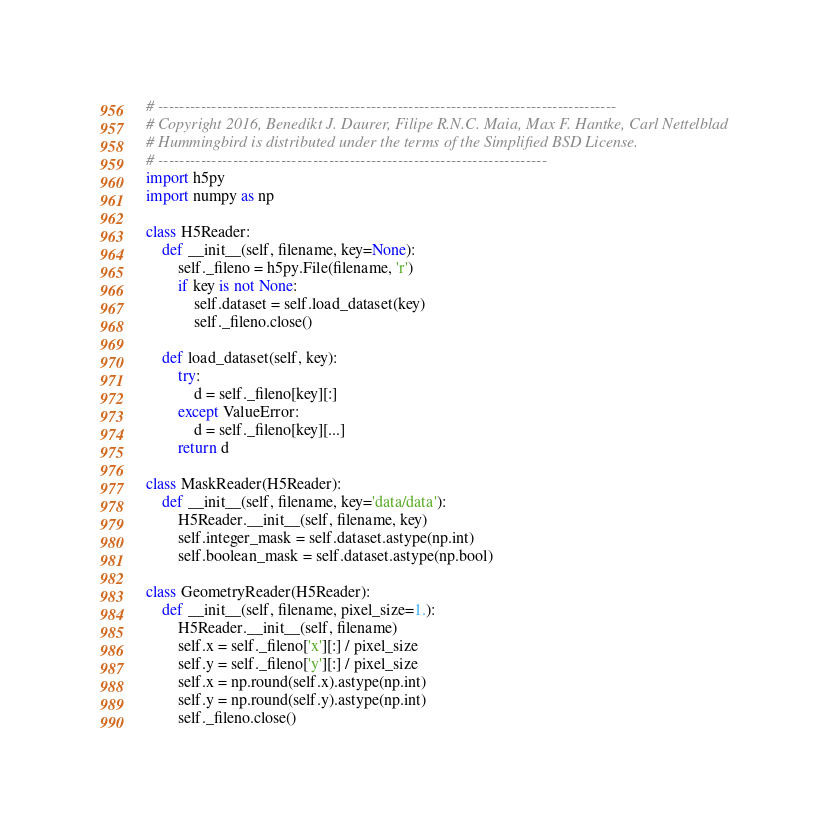<code> <loc_0><loc_0><loc_500><loc_500><_Python_># --------------------------------------------------------------------------------------
# Copyright 2016, Benedikt J. Daurer, Filipe R.N.C. Maia, Max F. Hantke, Carl Nettelblad
# Hummingbird is distributed under the terms of the Simplified BSD License.
# -------------------------------------------------------------------------
import h5py
import numpy as np

class H5Reader:
    def __init__(self, filename, key=None):
        self._fileno = h5py.File(filename, 'r')
        if key is not None:
            self.dataset = self.load_dataset(key)
            self._fileno.close()
            
    def load_dataset(self, key):
        try:
            d = self._fileno[key][:]
        except ValueError:
            d = self._fileno[key][...]
        return d
        
class MaskReader(H5Reader):
    def __init__(self, filename, key='data/data'):
        H5Reader.__init__(self, filename, key)
        self.integer_mask = self.dataset.astype(np.int)
        self.boolean_mask = self.dataset.astype(np.bool)

class GeometryReader(H5Reader):
    def __init__(self, filename, pixel_size=1.):
        H5Reader.__init__(self, filename)
        self.x = self._fileno['x'][:] / pixel_size
        self.y = self._fileno['y'][:] / pixel_size
        self.x = np.round(self.x).astype(np.int)
        self.y = np.round(self.y).astype(np.int)
        self._fileno.close()

</code> 